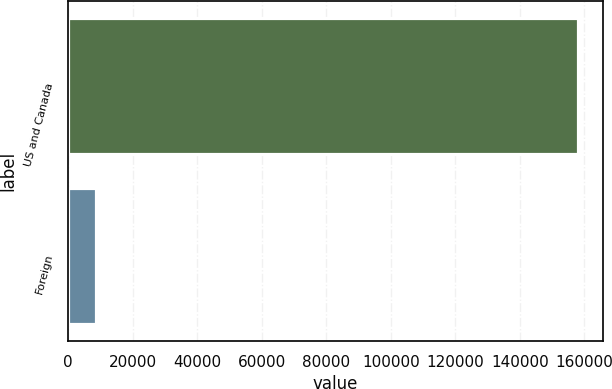Convert chart to OTSL. <chart><loc_0><loc_0><loc_500><loc_500><bar_chart><fcel>US and Canada<fcel>Foreign<nl><fcel>157929<fcel>8806<nl></chart> 